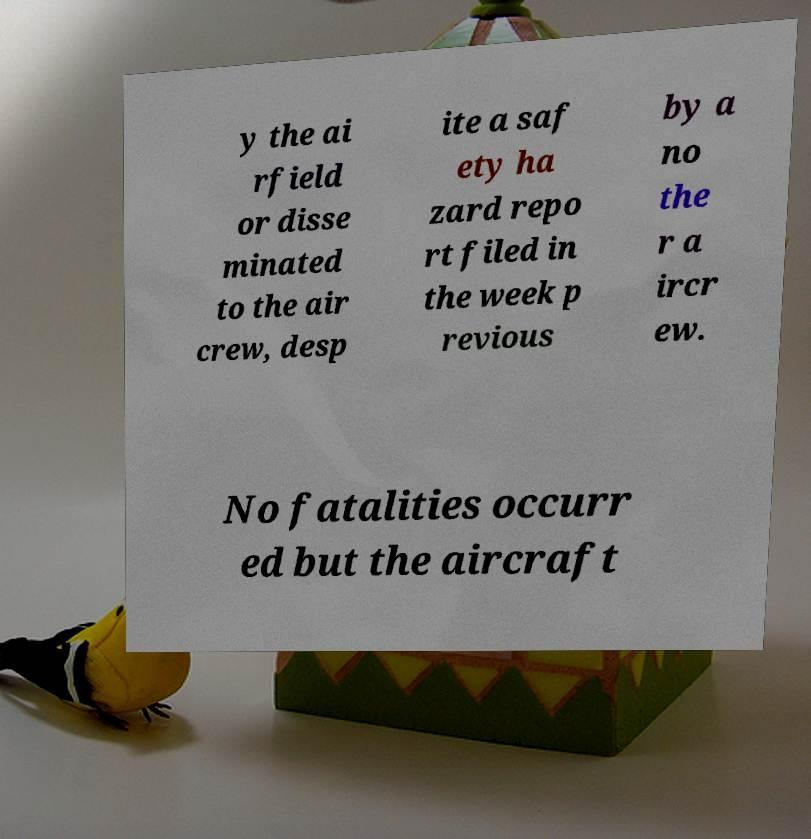Could you extract and type out the text from this image? y the ai rfield or disse minated to the air crew, desp ite a saf ety ha zard repo rt filed in the week p revious by a no the r a ircr ew. No fatalities occurr ed but the aircraft 